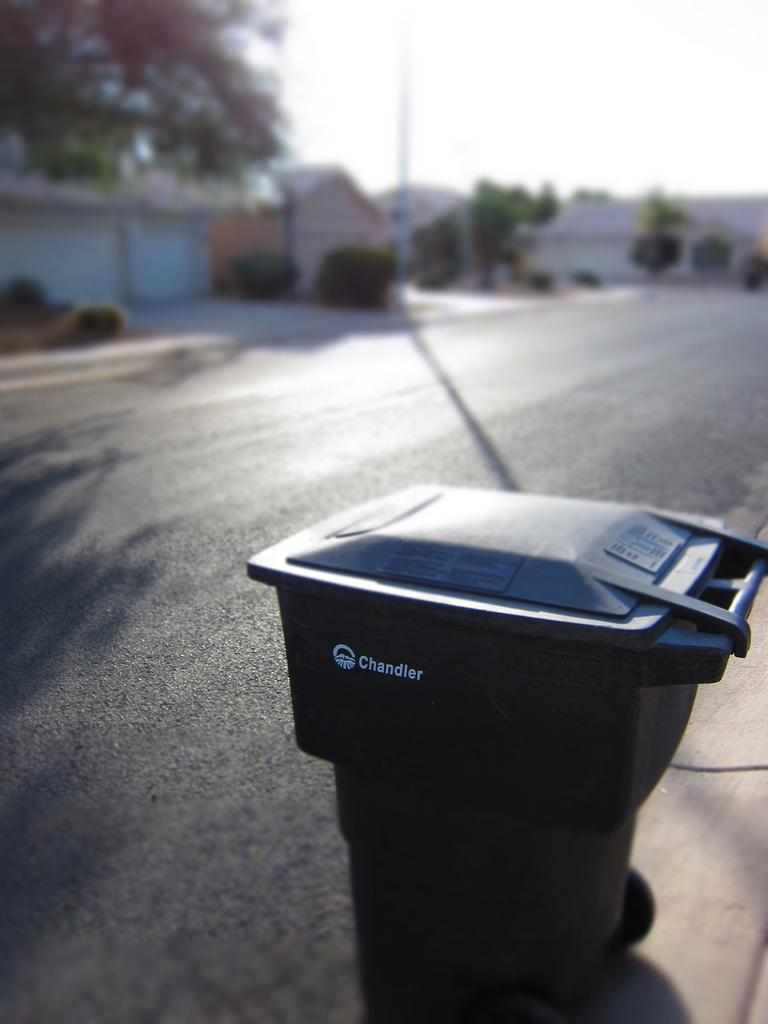What object in the image can be moved? There is a movable bin in the image. What can be seen in the distance in the image? In the background of the image, there is a road, trees, plants, houses, a pole, and the sky. Can you describe the natural elements visible in the image? The natural elements in the image include trees and plants. What type of science experiment is being conducted in the image? There is no science experiment present in the image. Is anyone wearing a mask in the image? There are no people or masks visible in the image. 